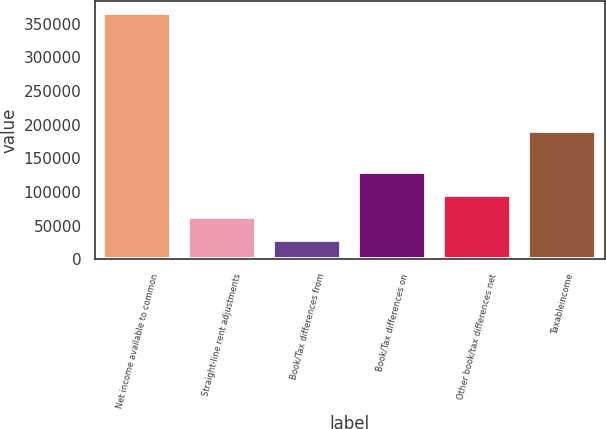Convert chart. <chart><loc_0><loc_0><loc_500><loc_500><bar_chart><fcel>Net income available to common<fcel>Straight-line rent adjustments<fcel>Book/Tax differences from<fcel>Book/Tax differences on<fcel>Other book/tax differences net<fcel>Taxableincome<nl><fcel>365322<fcel>62252.4<fcel>28578<fcel>129601<fcel>95926.8<fcel>190499<nl></chart> 